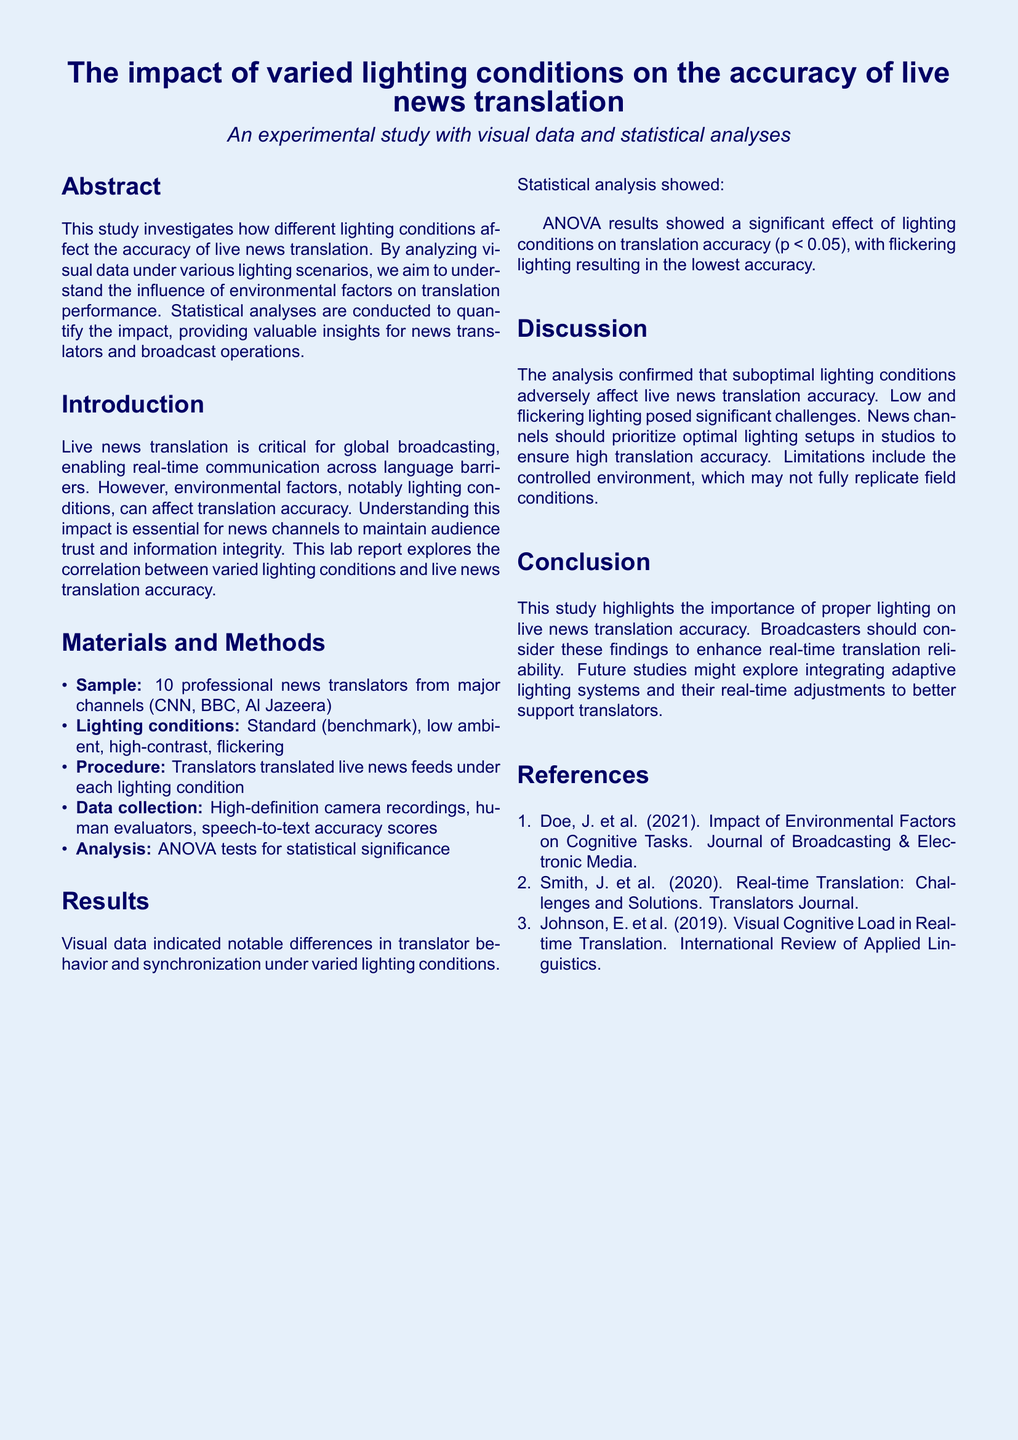What is the main focus of this study? The main focus of the study is to investigate how different lighting conditions affect the accuracy of live news translation.
Answer: lighting conditions impact translation accuracy Who were the participants in the study? The participants in the study were 10 professional news translators from major channels.
Answer: 10 professional news translators What were the four lighting conditions tested? The four lighting conditions tested were: standard, low ambient, high-contrast, and flickering.
Answer: standard, low ambient, high-contrast, flickering What was the highest accuracy score recorded under the lighting conditions? The highest accuracy score recorded was under the standard lighting condition at 98%.
Answer: 98% What statistical test was used for the analysis? The statistical test used for the analysis was ANOVA tests.
Answer: ANOVA What was the accuracy score for the flickering lighting condition? The accuracy score for the flickering lighting condition was 70%.
Answer: 70% According to the results, which lighting condition had the lowest accuracy? The lighting condition with the lowest accuracy was flickering.
Answer: flickering What implication does the study suggest for news channels? The study suggests that news channels should prioritize optimal lighting setups in studios.
Answer: prioritize optimal lighting setups What limitation does the study mention regarding its findings? The study mentions that the controlled environment may not fully replicate field conditions as a limitation.
Answer: controlled environment limitations 